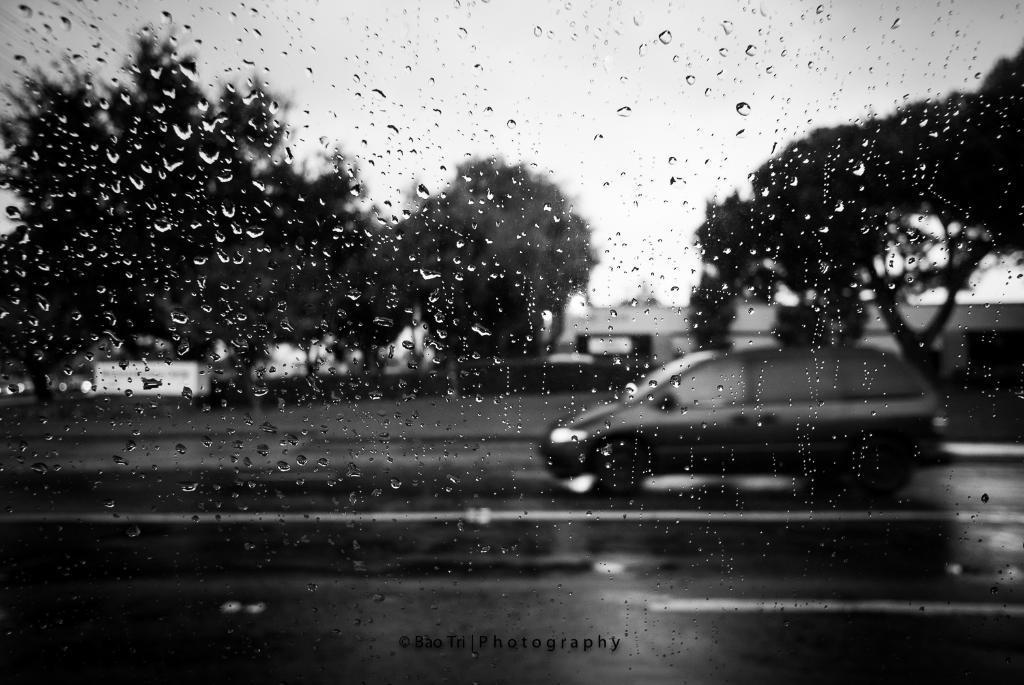Can you describe this image briefly? In this image we can see the water drops on glass and through the glass we can see a vehicle passing on the road. We can also see the trees and also the sky and a building. At the bottom we can see the text. 